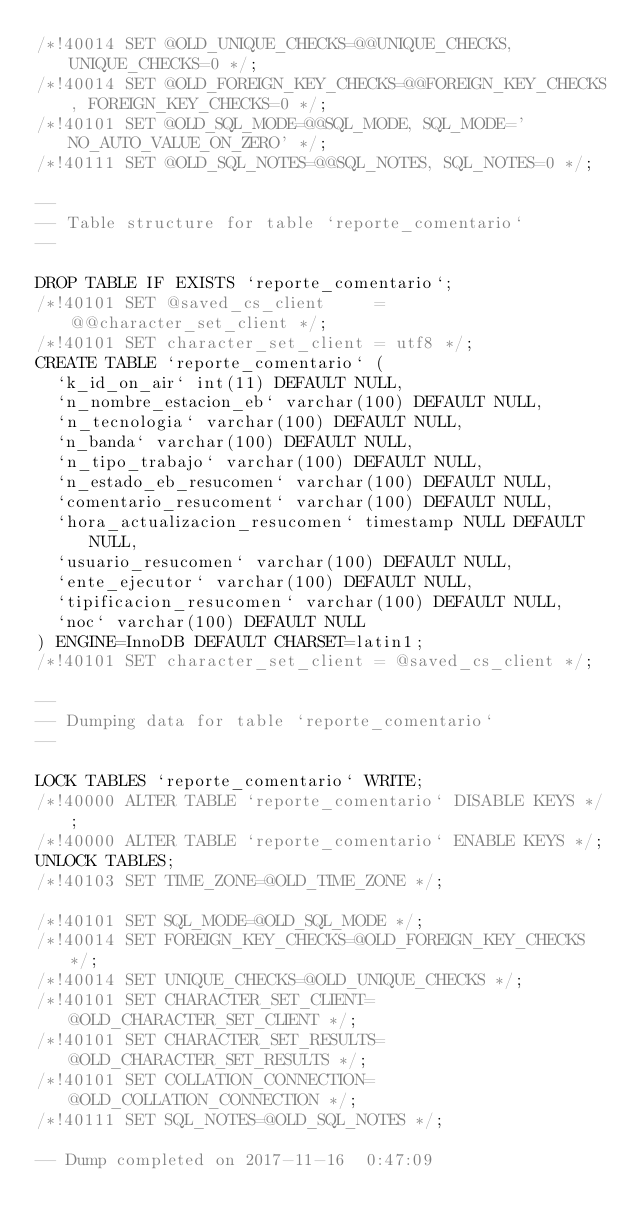Convert code to text. <code><loc_0><loc_0><loc_500><loc_500><_SQL_>/*!40014 SET @OLD_UNIQUE_CHECKS=@@UNIQUE_CHECKS, UNIQUE_CHECKS=0 */;
/*!40014 SET @OLD_FOREIGN_KEY_CHECKS=@@FOREIGN_KEY_CHECKS, FOREIGN_KEY_CHECKS=0 */;
/*!40101 SET @OLD_SQL_MODE=@@SQL_MODE, SQL_MODE='NO_AUTO_VALUE_ON_ZERO' */;
/*!40111 SET @OLD_SQL_NOTES=@@SQL_NOTES, SQL_NOTES=0 */;

--
-- Table structure for table `reporte_comentario`
--

DROP TABLE IF EXISTS `reporte_comentario`;
/*!40101 SET @saved_cs_client     = @@character_set_client */;
/*!40101 SET character_set_client = utf8 */;
CREATE TABLE `reporte_comentario` (
  `k_id_on_air` int(11) DEFAULT NULL,
  `n_nombre_estacion_eb` varchar(100) DEFAULT NULL,
  `n_tecnologia` varchar(100) DEFAULT NULL,
  `n_banda` varchar(100) DEFAULT NULL,
  `n_tipo_trabajo` varchar(100) DEFAULT NULL,
  `n_estado_eb_resucomen` varchar(100) DEFAULT NULL,
  `comentario_resucoment` varchar(100) DEFAULT NULL,
  `hora_actualizacion_resucomen` timestamp NULL DEFAULT NULL,
  `usuario_resucomen` varchar(100) DEFAULT NULL,
  `ente_ejecutor` varchar(100) DEFAULT NULL,
  `tipificacion_resucomen` varchar(100) DEFAULT NULL,
  `noc` varchar(100) DEFAULT NULL
) ENGINE=InnoDB DEFAULT CHARSET=latin1;
/*!40101 SET character_set_client = @saved_cs_client */;

--
-- Dumping data for table `reporte_comentario`
--

LOCK TABLES `reporte_comentario` WRITE;
/*!40000 ALTER TABLE `reporte_comentario` DISABLE KEYS */;
/*!40000 ALTER TABLE `reporte_comentario` ENABLE KEYS */;
UNLOCK TABLES;
/*!40103 SET TIME_ZONE=@OLD_TIME_ZONE */;

/*!40101 SET SQL_MODE=@OLD_SQL_MODE */;
/*!40014 SET FOREIGN_KEY_CHECKS=@OLD_FOREIGN_KEY_CHECKS */;
/*!40014 SET UNIQUE_CHECKS=@OLD_UNIQUE_CHECKS */;
/*!40101 SET CHARACTER_SET_CLIENT=@OLD_CHARACTER_SET_CLIENT */;
/*!40101 SET CHARACTER_SET_RESULTS=@OLD_CHARACTER_SET_RESULTS */;
/*!40101 SET COLLATION_CONNECTION=@OLD_COLLATION_CONNECTION */;
/*!40111 SET SQL_NOTES=@OLD_SQL_NOTES */;

-- Dump completed on 2017-11-16  0:47:09
</code> 